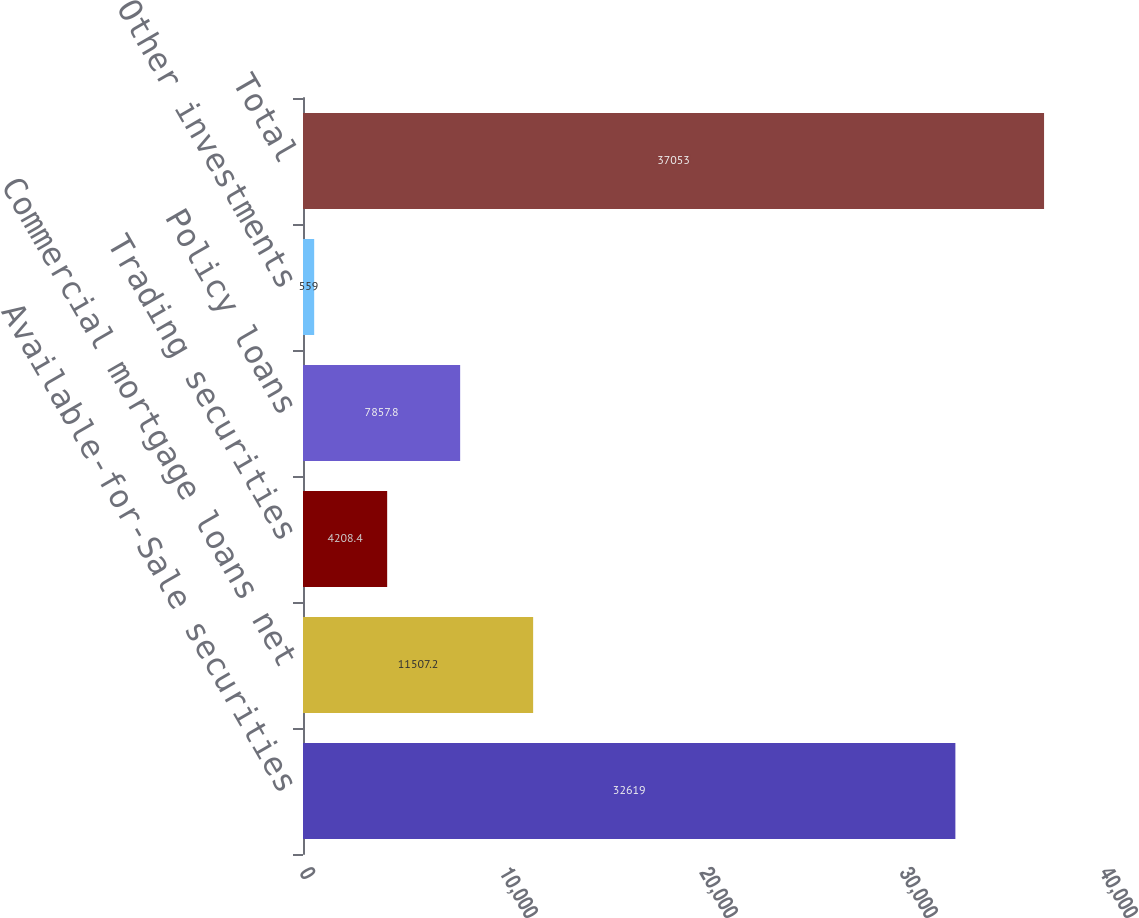Convert chart to OTSL. <chart><loc_0><loc_0><loc_500><loc_500><bar_chart><fcel>Available-for-Sale securities<fcel>Commercial mortgage loans net<fcel>Trading securities<fcel>Policy loans<fcel>Other investments<fcel>Total<nl><fcel>32619<fcel>11507.2<fcel>4208.4<fcel>7857.8<fcel>559<fcel>37053<nl></chart> 